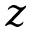<formula> <loc_0><loc_0><loc_500><loc_500>z</formula> 